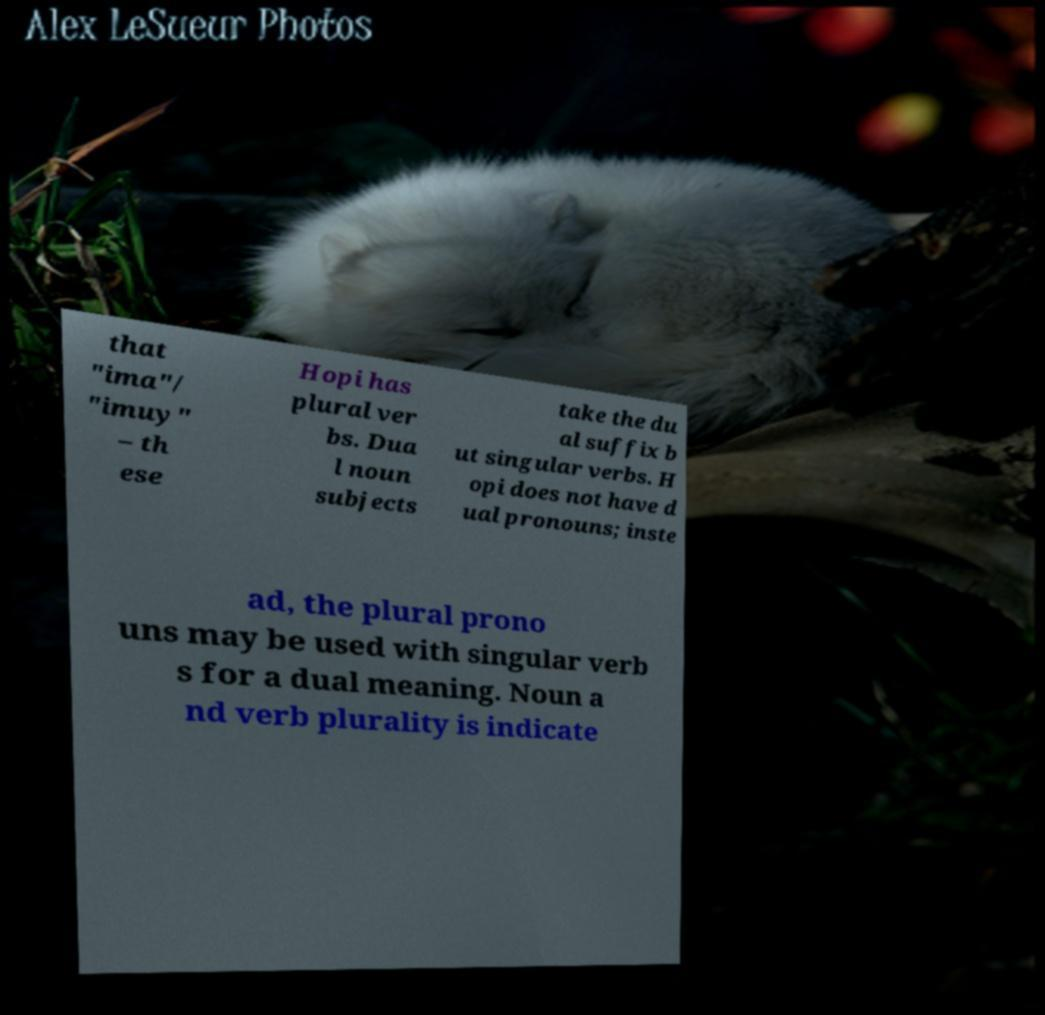Could you extract and type out the text from this image? that "ima"/ "imuy" – th ese Hopi has plural ver bs. Dua l noun subjects take the du al suffix b ut singular verbs. H opi does not have d ual pronouns; inste ad, the plural prono uns may be used with singular verb s for a dual meaning. Noun a nd verb plurality is indicate 